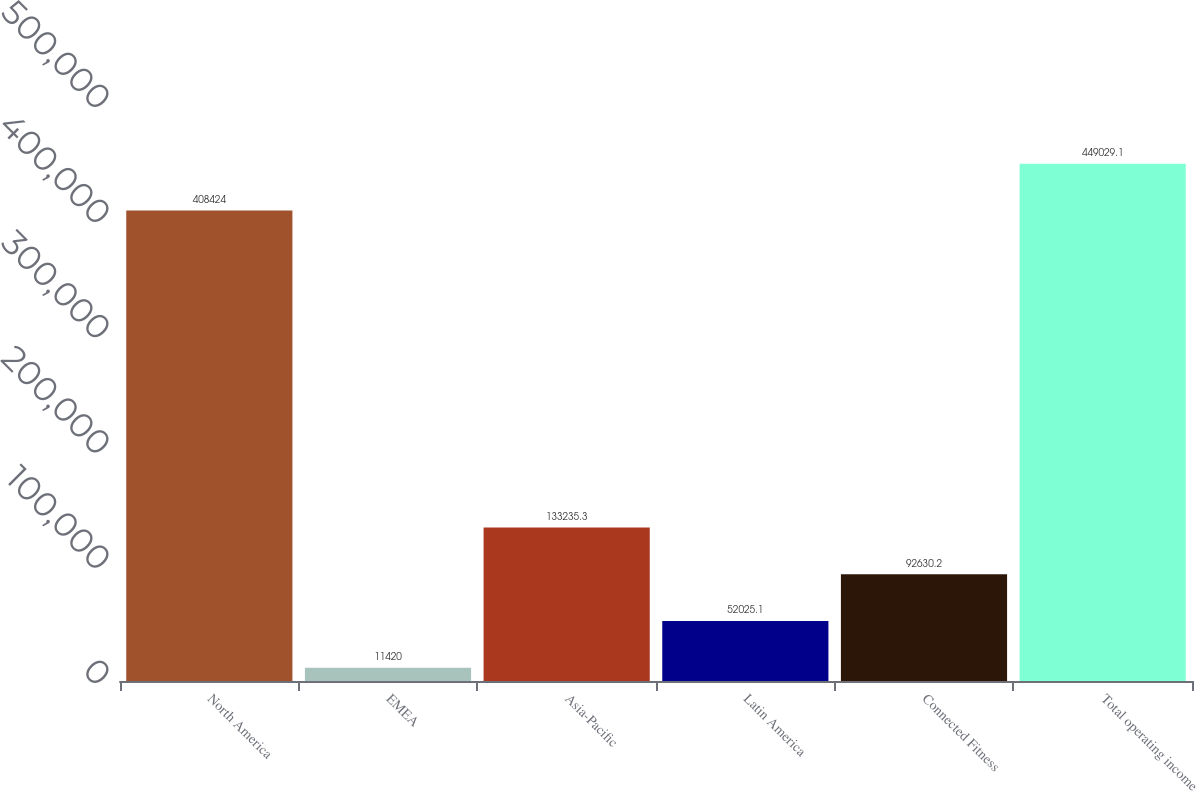<chart> <loc_0><loc_0><loc_500><loc_500><bar_chart><fcel>North America<fcel>EMEA<fcel>Asia-Pacific<fcel>Latin America<fcel>Connected Fitness<fcel>Total operating income<nl><fcel>408424<fcel>11420<fcel>133235<fcel>52025.1<fcel>92630.2<fcel>449029<nl></chart> 